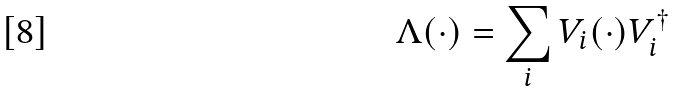Convert formula to latex. <formula><loc_0><loc_0><loc_500><loc_500>\Lambda ( \cdot ) = \sum _ { i } V _ { i } ( \cdot ) V _ { i } ^ { \dagger }</formula> 